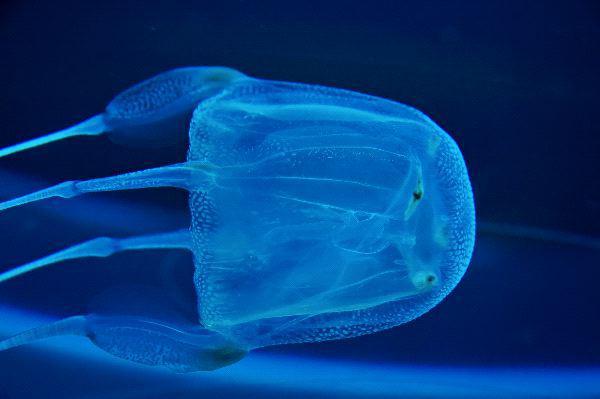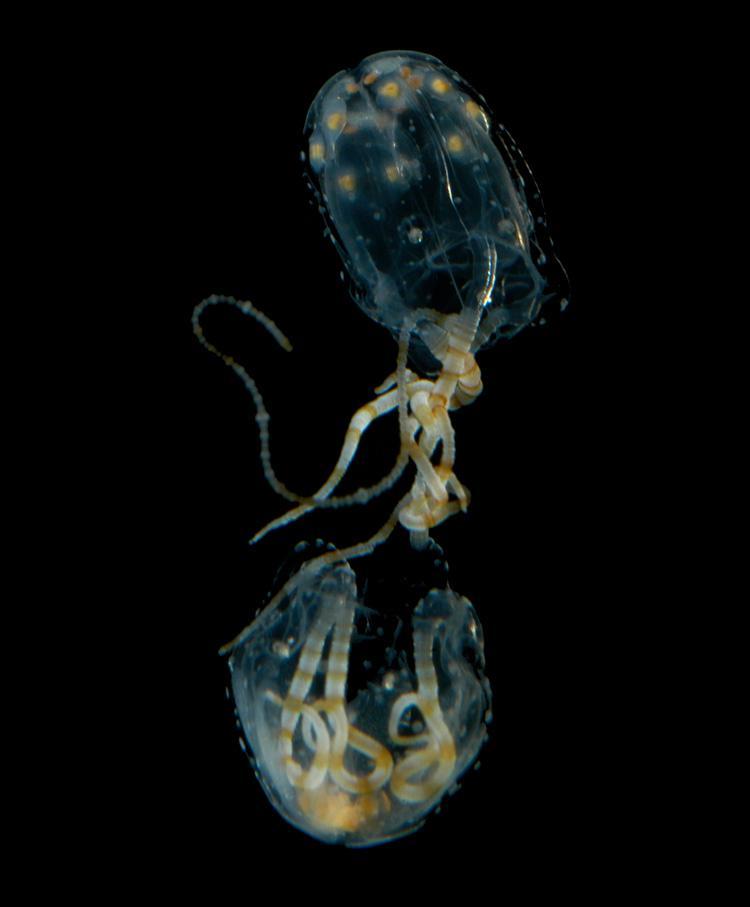The first image is the image on the left, the second image is the image on the right. Evaluate the accuracy of this statement regarding the images: "One of the images shows a single fish being pulled in on the tentacles of a lone jellyfish". Is it true? Answer yes or no. No. The first image is the image on the left, the second image is the image on the right. Assess this claim about the two images: "There is at least one moving jellyfish with a rounded crown lit up blue due to the blue background.". Correct or not? Answer yes or no. Yes. 